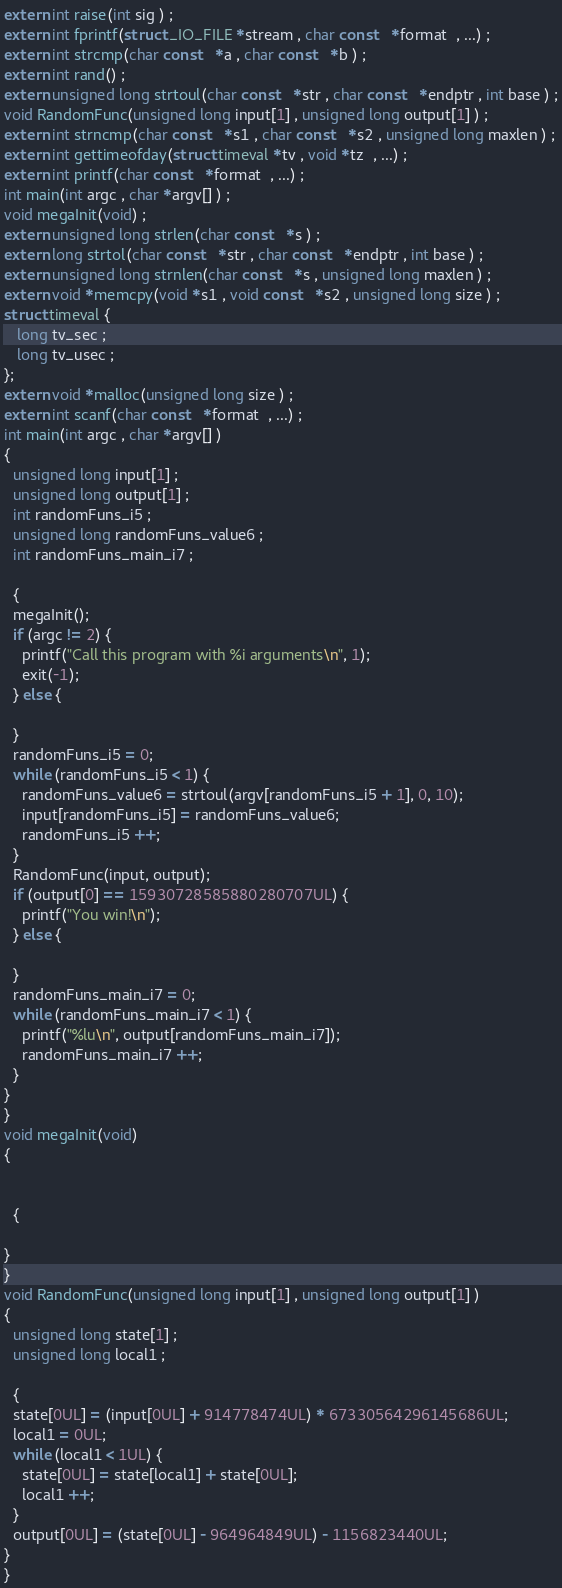<code> <loc_0><loc_0><loc_500><loc_500><_C_>extern int raise(int sig ) ;
extern int fprintf(struct _IO_FILE *stream , char const   *format  , ...) ;
extern int strcmp(char const   *a , char const   *b ) ;
extern int rand() ;
extern unsigned long strtoul(char const   *str , char const   *endptr , int base ) ;
void RandomFunc(unsigned long input[1] , unsigned long output[1] ) ;
extern int strncmp(char const   *s1 , char const   *s2 , unsigned long maxlen ) ;
extern int gettimeofday(struct timeval *tv , void *tz  , ...) ;
extern int printf(char const   *format  , ...) ;
int main(int argc , char *argv[] ) ;
void megaInit(void) ;
extern unsigned long strlen(char const   *s ) ;
extern long strtol(char const   *str , char const   *endptr , int base ) ;
extern unsigned long strnlen(char const   *s , unsigned long maxlen ) ;
extern void *memcpy(void *s1 , void const   *s2 , unsigned long size ) ;
struct timeval {
   long tv_sec ;
   long tv_usec ;
};
extern void *malloc(unsigned long size ) ;
extern int scanf(char const   *format  , ...) ;
int main(int argc , char *argv[] ) 
{ 
  unsigned long input[1] ;
  unsigned long output[1] ;
  int randomFuns_i5 ;
  unsigned long randomFuns_value6 ;
  int randomFuns_main_i7 ;

  {
  megaInit();
  if (argc != 2) {
    printf("Call this program with %i arguments\n", 1);
    exit(-1);
  } else {

  }
  randomFuns_i5 = 0;
  while (randomFuns_i5 < 1) {
    randomFuns_value6 = strtoul(argv[randomFuns_i5 + 1], 0, 10);
    input[randomFuns_i5] = randomFuns_value6;
    randomFuns_i5 ++;
  }
  RandomFunc(input, output);
  if (output[0] == 15930728585880280707UL) {
    printf("You win!\n");
  } else {

  }
  randomFuns_main_i7 = 0;
  while (randomFuns_main_i7 < 1) {
    printf("%lu\n", output[randomFuns_main_i7]);
    randomFuns_main_i7 ++;
  }
}
}
void megaInit(void) 
{ 


  {

}
}
void RandomFunc(unsigned long input[1] , unsigned long output[1] ) 
{ 
  unsigned long state[1] ;
  unsigned long local1 ;

  {
  state[0UL] = (input[0UL] + 914778474UL) * 67330564296145686UL;
  local1 = 0UL;
  while (local1 < 1UL) {
    state[0UL] = state[local1] + state[0UL];
    local1 ++;
  }
  output[0UL] = (state[0UL] - 964964849UL) - 1156823440UL;
}
}
</code> 